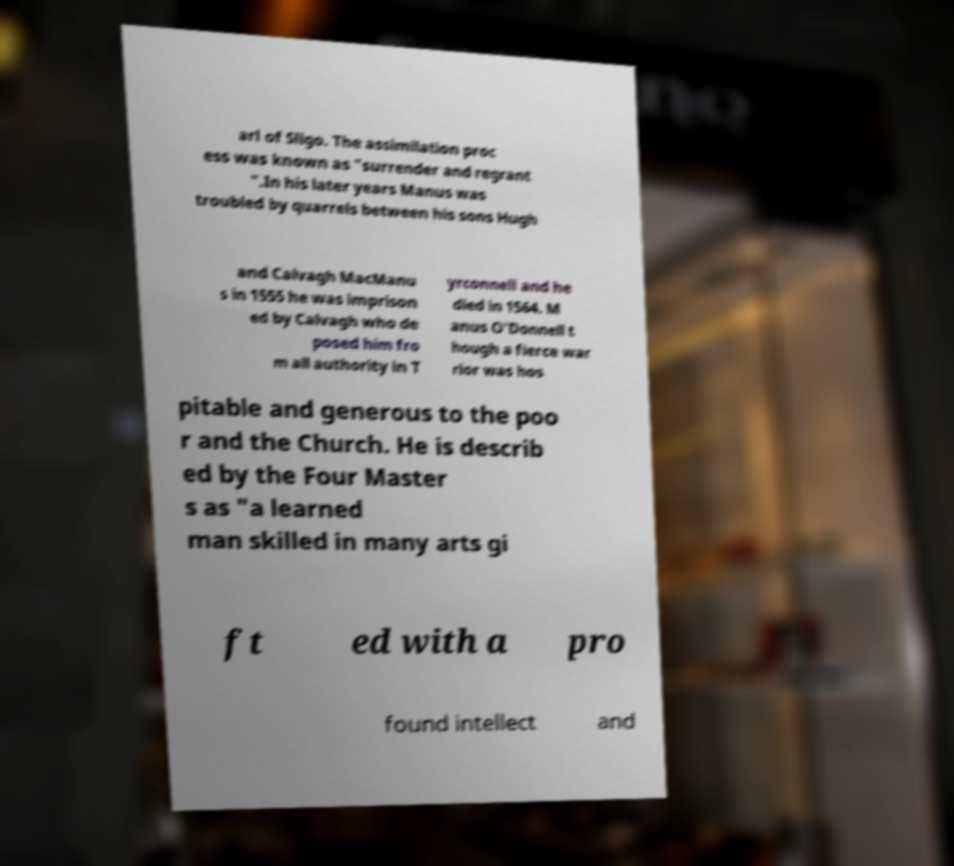Please identify and transcribe the text found in this image. arl of Sligo. The assimilation proc ess was known as "surrender and regrant ".In his later years Manus was troubled by quarrels between his sons Hugh and Calvagh MacManu s in 1555 he was imprison ed by Calvagh who de posed him fro m all authority in T yrconnell and he died in 1564. M anus O'Donnell t hough a fierce war rior was hos pitable and generous to the poo r and the Church. He is describ ed by the Four Master s as "a learned man skilled in many arts gi ft ed with a pro found intellect and 